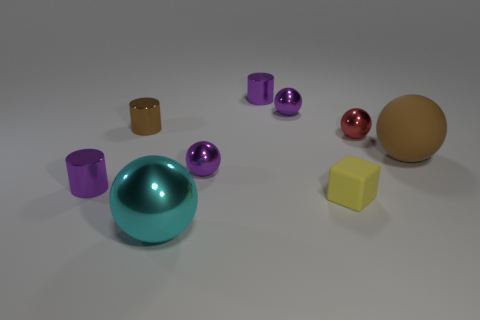Subtract all red spheres. How many spheres are left? 4 Subtract all tiny red balls. How many balls are left? 4 Subtract all blue spheres. Subtract all cyan blocks. How many spheres are left? 5 Add 1 red metallic balls. How many objects exist? 10 Subtract all cubes. How many objects are left? 8 Subtract all green metallic spheres. Subtract all small brown things. How many objects are left? 8 Add 6 brown rubber things. How many brown rubber things are left? 7 Add 1 purple rubber cylinders. How many purple rubber cylinders exist? 1 Subtract 0 green spheres. How many objects are left? 9 